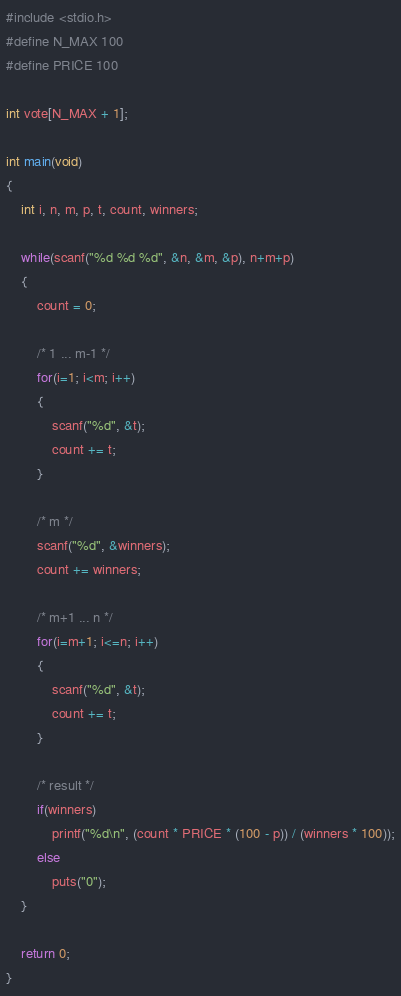Convert code to text. <code><loc_0><loc_0><loc_500><loc_500><_C_>#include <stdio.h>
#define N_MAX 100
#define PRICE 100

int vote[N_MAX + 1];

int main(void)
{
    int i, n, m, p, t, count, winners;

    while(scanf("%d %d %d", &n, &m, &p), n+m+p)
    {
        count = 0;

        /* 1 ... m-1 */
        for(i=1; i<m; i++)
        {
            scanf("%d", &t);
            count += t;
        }

        /* m */
        scanf("%d", &winners);
        count += winners;

        /* m+1 ... n */
        for(i=m+1; i<=n; i++)
        {
            scanf("%d", &t);
            count += t;
        }

        /* result */
        if(winners)
            printf("%d\n", (count * PRICE * (100 - p)) / (winners * 100));
        else
            puts("0");
    }

    return 0;
}</code> 